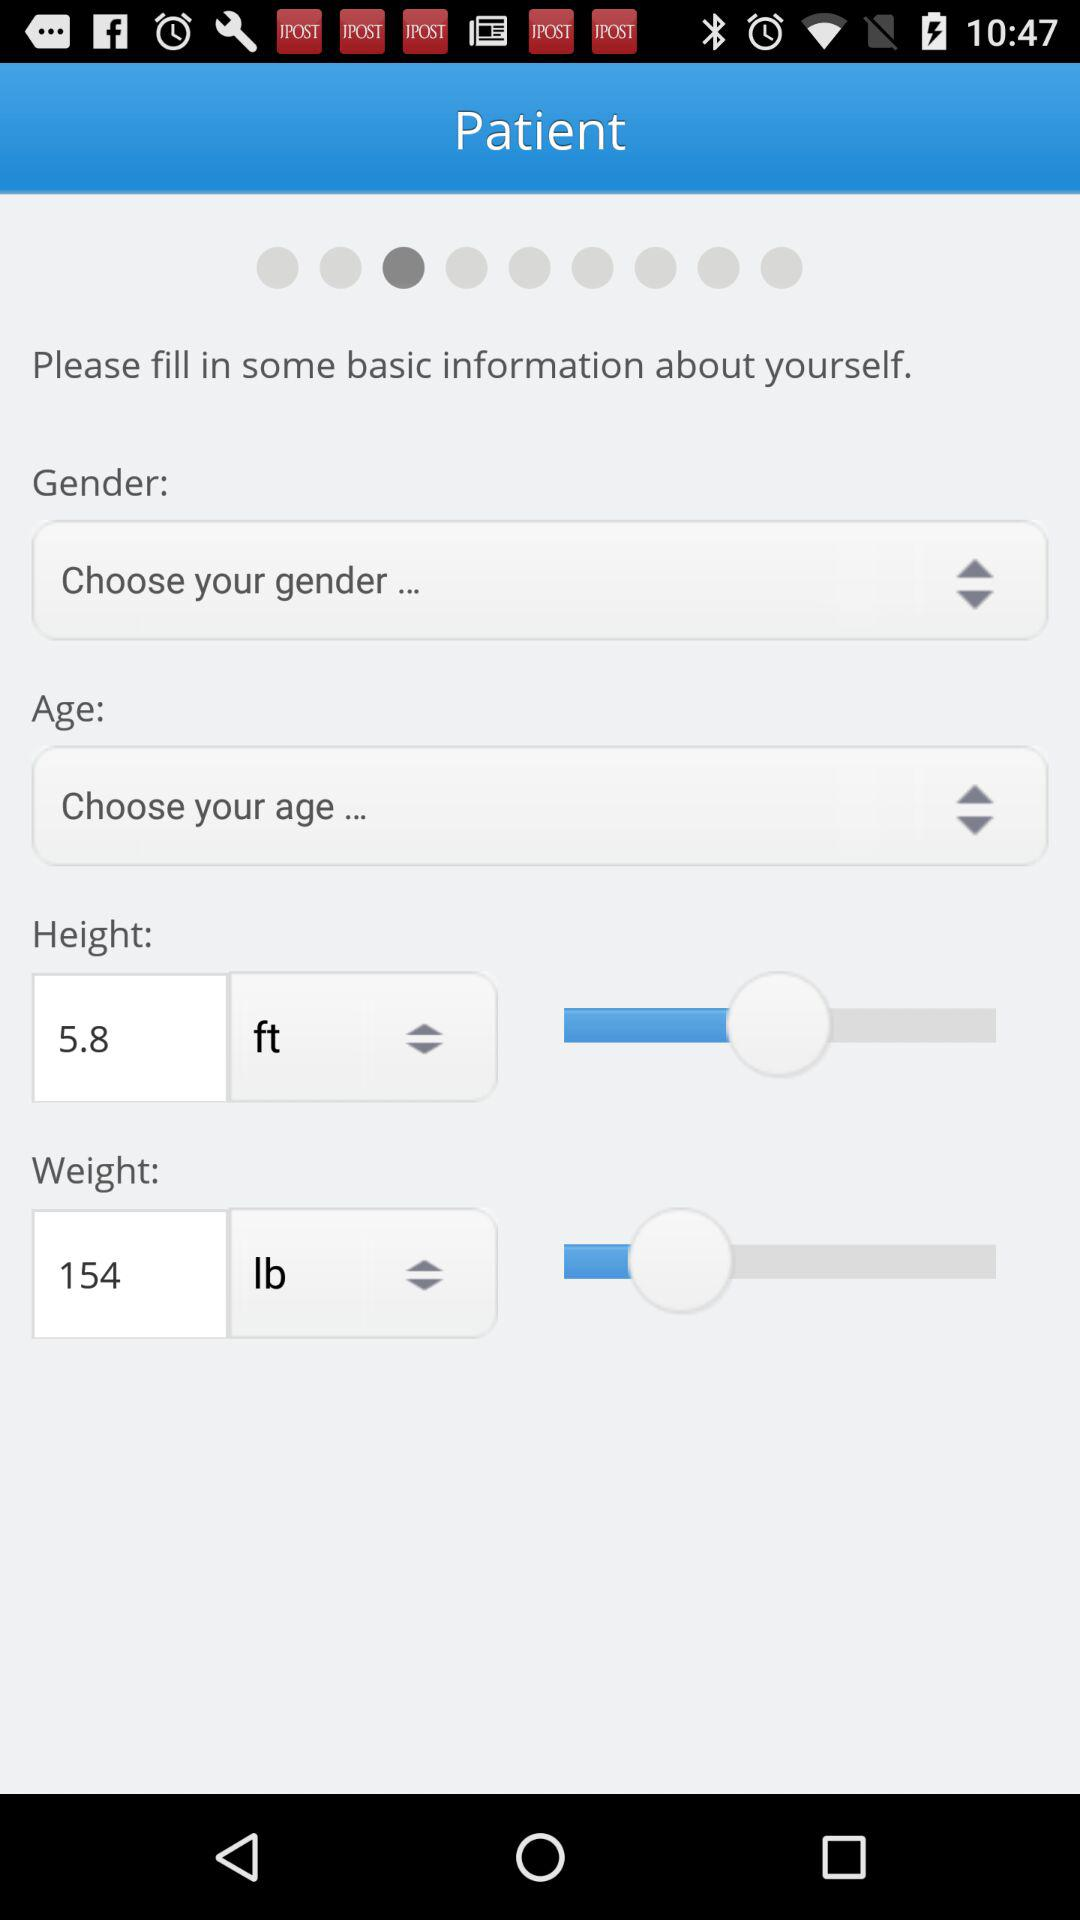What is the unit of weight? The unit of weight is pounds. 